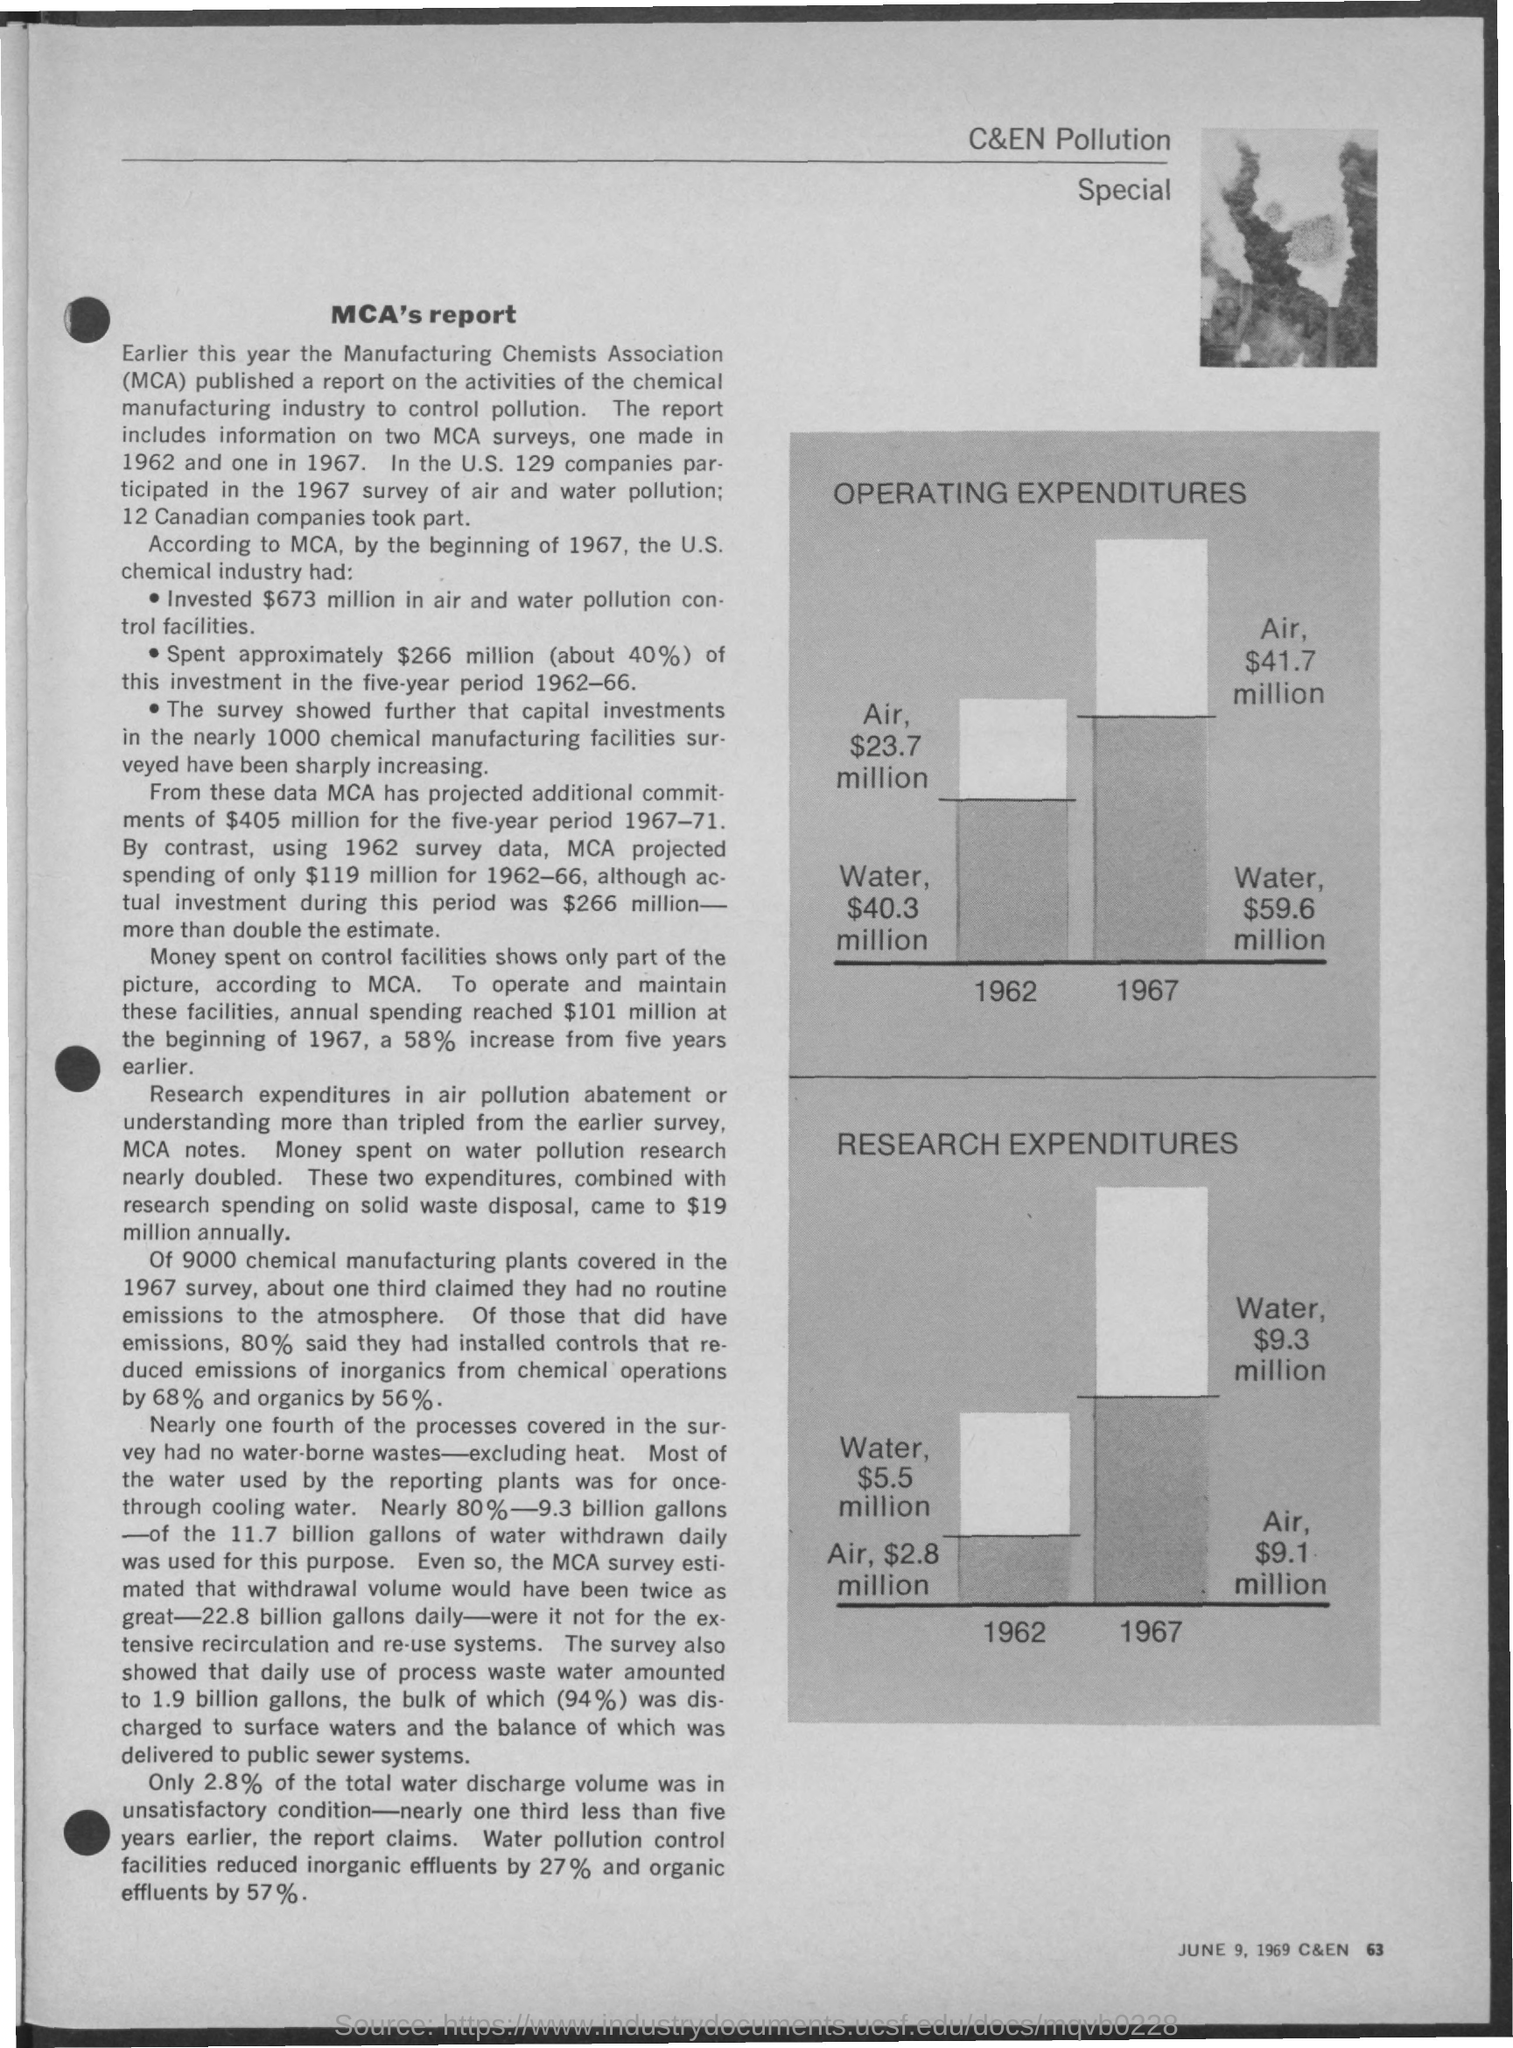Indicate a few pertinent items in this graphic. The Ministry of Chemicals and Fertilizers (MCA) published a report on the activities of the chemical manufacturing industry to control pollution earlier this year. The MCA surveys were conducted in 1962 and 1967, as per the document. The United States chemical industry has invested $673 million in air and water pollution control facilities, as stated by the Mine Safety and Health Administration, The fullform of MCA is Manufacturing Chemists Association. 